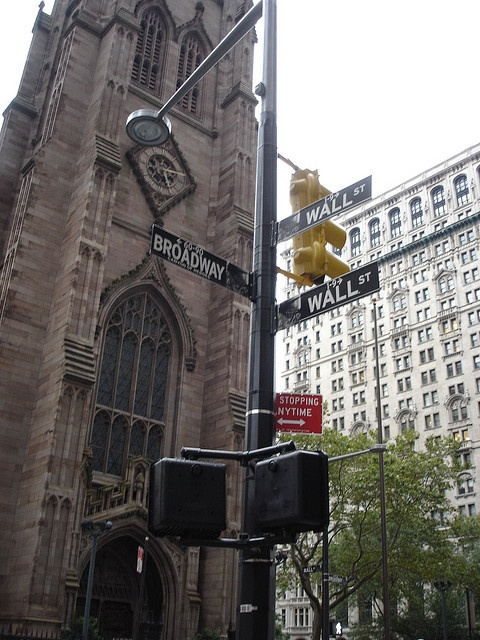Describe the objects in this image and their specific colors. I can see traffic light in white, black, gray, and darkgray tones, traffic light in white, black, gray, and darkgray tones, traffic light in white, olive, gray, and darkgray tones, and clock in white, gray, and black tones in this image. 